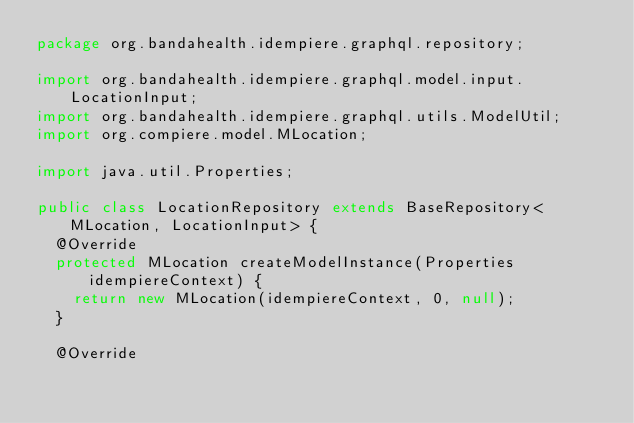<code> <loc_0><loc_0><loc_500><loc_500><_Java_>package org.bandahealth.idempiere.graphql.repository;

import org.bandahealth.idempiere.graphql.model.input.LocationInput;
import org.bandahealth.idempiere.graphql.utils.ModelUtil;
import org.compiere.model.MLocation;

import java.util.Properties;

public class LocationRepository extends BaseRepository<MLocation, LocationInput> {
	@Override
	protected MLocation createModelInstance(Properties idempiereContext) {
		return new MLocation(idempiereContext, 0, null);
	}

	@Override</code> 